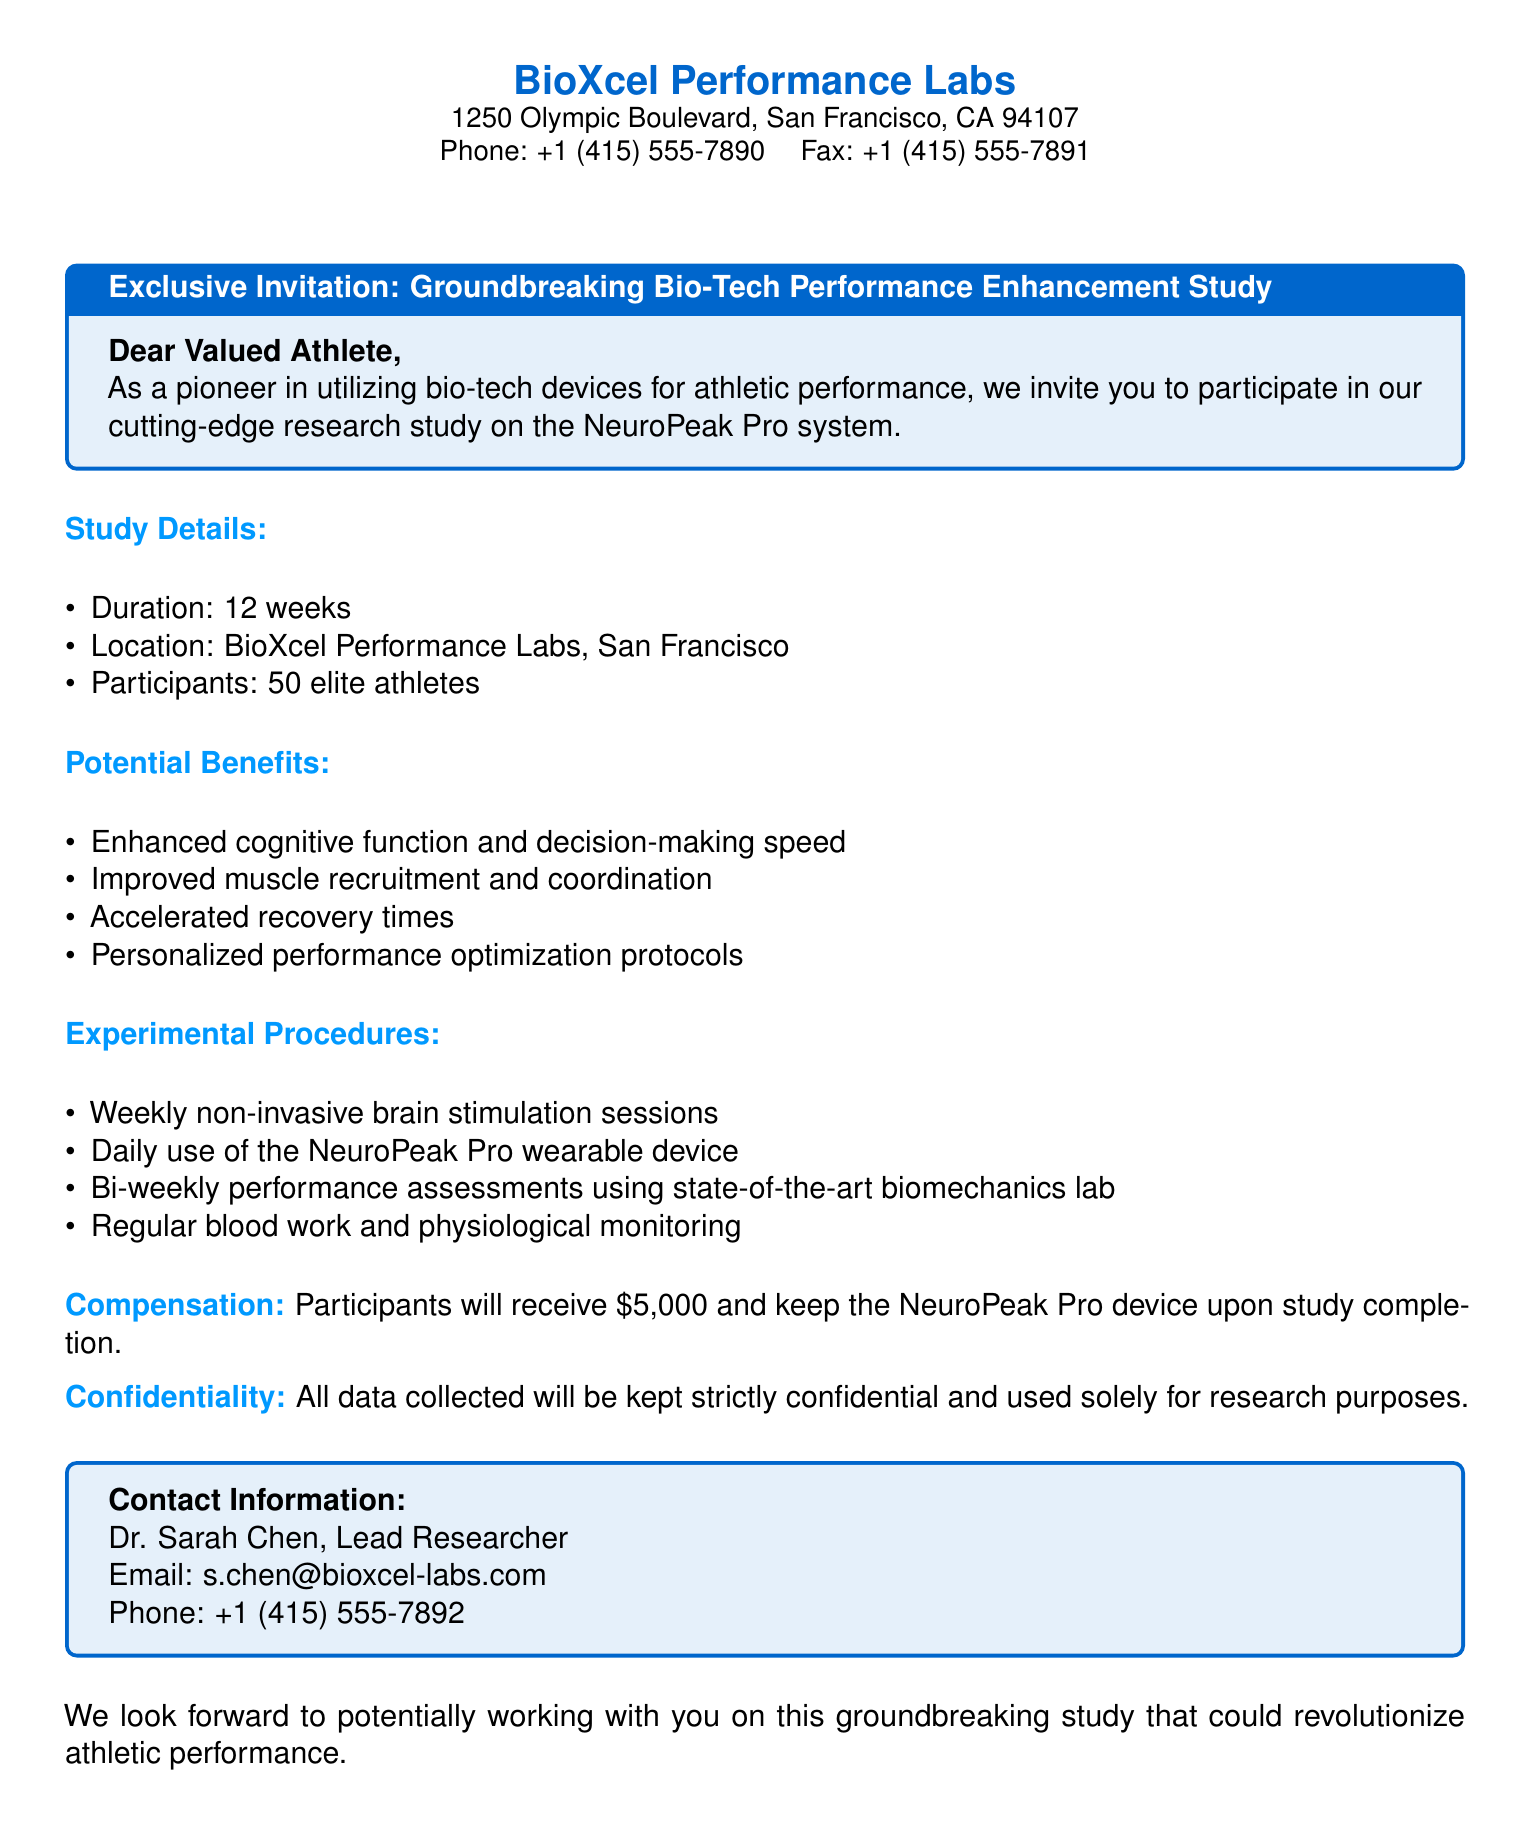What is the duration of the study? The duration of the study is specified in the document under study details.
Answer: 12 weeks Where is the study located? The location of the study is provided in the document's study details section.
Answer: BioXcel Performance Labs, San Francisco How many elite athletes will participate? The document indicates the number of participants in the study details section.
Answer: 50 elite athletes What is one potential benefit mentioned? Potential benefits are listed in the document. Any of them can be an answer.
Answer: Enhanced cognitive function and decision-making speed What is the compensation for participants? The compensation details can be found towards the end of the document.
Answer: $5,000 What type of device will participants keep after the study? The type of device is mentioned in the compensation section of the document.
Answer: NeuroPeak Pro device How often will performance assessments occur? The frequency of performance assessments is mentioned in the experimental procedures section.
Answer: Bi-weekly Who is the lead researcher for the study? The lead researcher’s name is provided in the contact information section.
Answer: Dr. Sarah Chen What type of sessions will participants undergo weekly? The type of sessions is outlined in the experimental procedures section.
Answer: Non-invasive brain stimulation sessions 